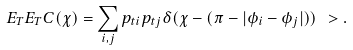<formula> <loc_0><loc_0><loc_500><loc_500>E _ { T } E _ { T } C ( \chi ) = \sum _ { i , j } p _ { t i } p _ { t j } \delta ( \chi - ( \pi - | \phi _ { i } - \phi _ { j } | ) ) \ > .</formula> 